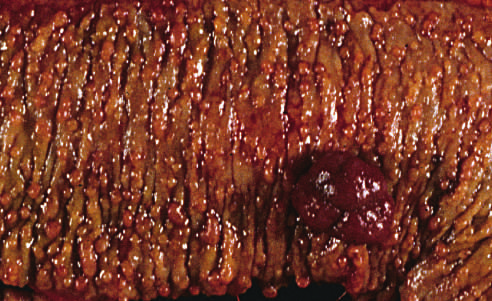what are hundreds of small colonic polyps present along with?
Answer the question using a single word or phrase. A dominant polyp 